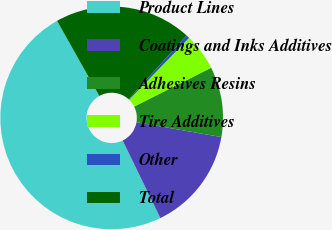Convert chart to OTSL. <chart><loc_0><loc_0><loc_500><loc_500><pie_chart><fcel>Product Lines<fcel>Coatings and Inks Additives<fcel>Adhesives Resins<fcel>Tire Additives<fcel>Other<fcel>Total<nl><fcel>49.03%<fcel>15.05%<fcel>10.19%<fcel>5.34%<fcel>0.49%<fcel>19.9%<nl></chart> 